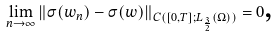<formula> <loc_0><loc_0><loc_500><loc_500>\underset { n \rightarrow \infty } { \lim } \left \| \sigma ( w _ { n } ) - \sigma ( w ) \right \| _ { C ( [ 0 , T ] ; L _ { \frac { 3 } { 2 } } ( \Omega ) ) } = 0 \text {,}</formula> 